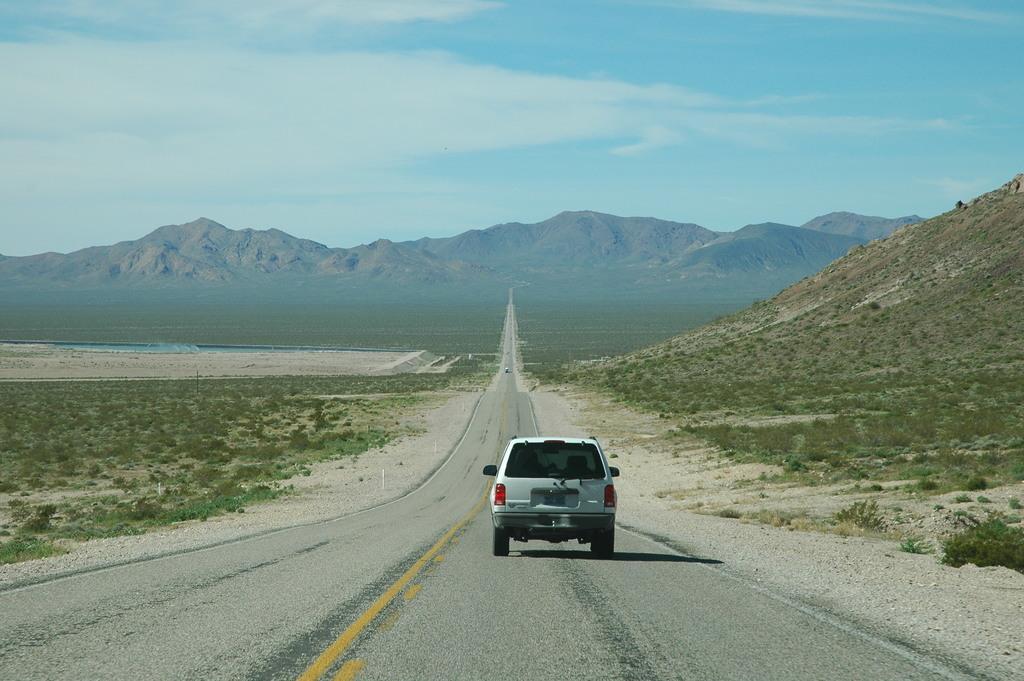Could you give a brief overview of what you see in this image? In this image there is a car on a road, on the left side there is a grassland, on the right there is a mountain, in the background there are mountains and the sky. 